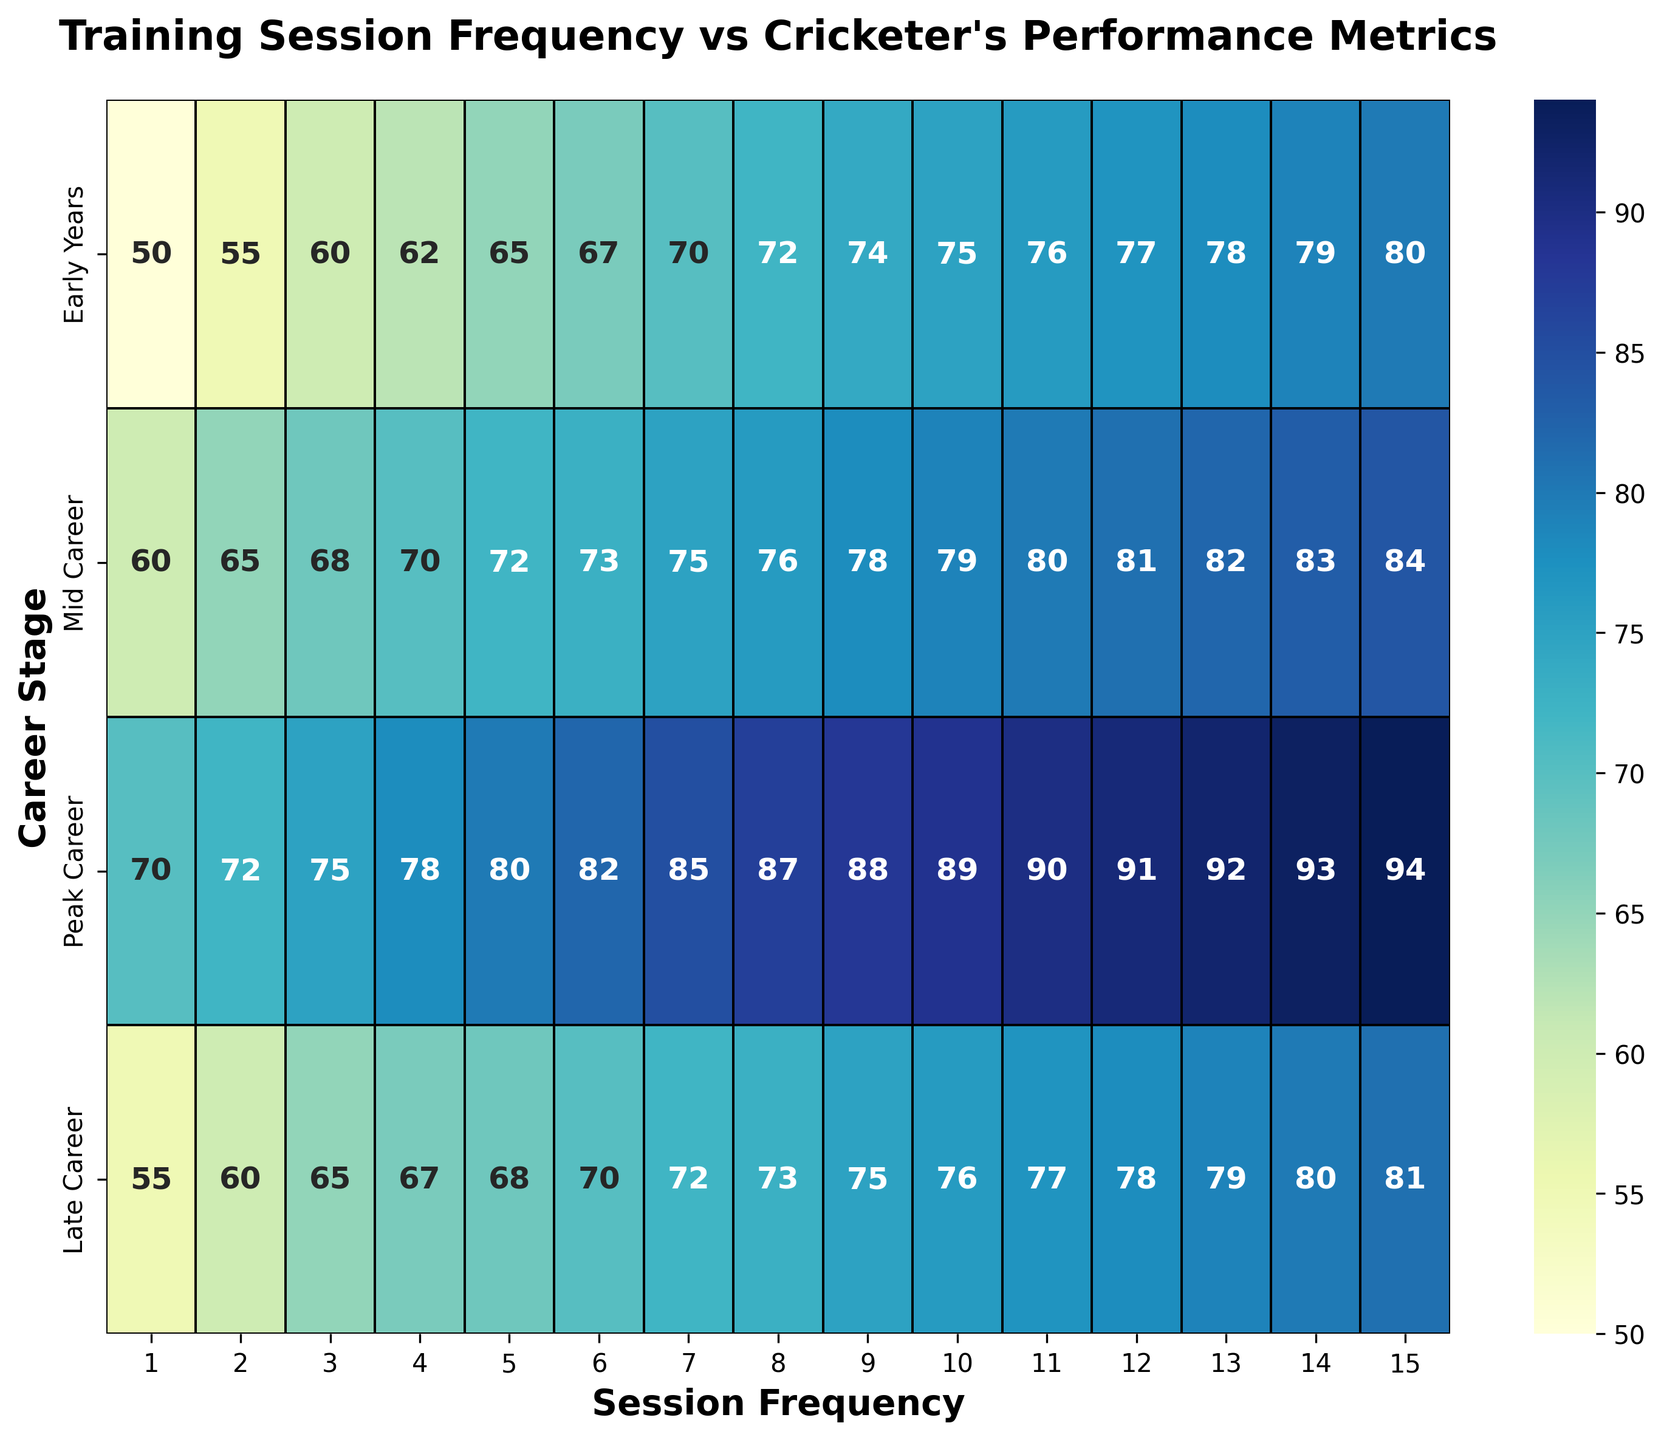What is the performance metric for Session Frequency 10 during Peak Career? The value on the heatmap where Session Frequency is 10 and Career Stage is Peak Career is 89.
Answer: 89 Which career stage exhibits the highest performance metric for Session Frequency 5? For Session Frequency 5, the values for the career stages are Early Years (65), Mid Career (72), Peak Career (80), and Late Career (68). Peak Career has the highest value.
Answer: Peak Career What is the difference in the performance metrics between Early Years and Late Career for Session Frequency 8? For Session Frequency 8, the performance metric for Early Years is 72 and for Late Career is 73. The difference is 73 - 72 = 1.
Answer: 1 How does the performance metric change from Early to Peak Career for Session Frequency 7? For Session Frequency 7, the performance metrics are Early Years (70), Mid Career (75), and Peak Career (85). From Early to Peak Career, the metric increases by 85 - 70 = 15.
Answer: 15 What is the average performance metric for Session Frequency 1 across all career stages? For Session Frequency 1, the performance metrics are: Early Years (50), Mid Career (60), Peak Career (70), and Late Career (55). Sum these values to get 50 + 60 + 70 + 55 = 235. The average is 235 / 4 = 58.75.
Answer: 58.75 Which Session Frequency has the highest performance metric during the Early Years? For the Early Years, the performance metrics are 50, 55, 60, 62, 65, 67, 70, 72, 74, 75, 76, 77, 78, 79, 80. The highest value is 80 at Session Frequency 15.
Answer: 15 Does the performance metric for Mid Career ever equal the performance metric for Peak Career? Scan the heatmap for overlap values between Mid Career and Peak Career. The Mid Career values are 60, 65, 68, 70, 72, 73, 75, 76, 78, 79, 80, 81, 82, 83, 84 and Peak Career values are 70, 72, 75, 78, 80, 82, 85, 87, 88, 89, 90, 91, 92, 93, 94. The common values are 70, 72, 75, 78, and 80.
Answer: Yes Which Session Frequency shows the smallest increase in performance from Mid Career to Late Career? For each Session Frequency, calculate the difference between Mid Career and Late Career. The differences are 0, 0, 0, -3, -4, -3, -3, -3, -3, -3, -3, -3, -3, -3, -3. The smallest increase (actually a decrease) is -4 for Session Frequency 5.
Answer: 5 How many times does the performance metric increase by 2 from one Session Frequency to the next within the Peak Career stage? For Peak Career, calculate the difference between consecutive Session Frequencies: 2, 3, 3, 2, 2, 3, 2, 1, 1, 1, 1, 1, 1, 1. There are 2 instances where the increase is exactly 2.
Answer: 2 